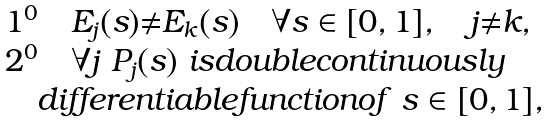<formula> <loc_0><loc_0><loc_500><loc_500>\begin{array} { l } 1 ^ { 0 } \quad E _ { j } ( s ) { \neq } E _ { k } ( s ) \quad \forall s \in [ 0 , 1 ] , \quad j { \neq } k , \\ 2 ^ { 0 } \quad \forall j \ P _ { j } ( s ) \ i s d o u b l e c o n t i n u o u s l y \\ \quad d i f f e r e n t i a b l e f u n c t i o n o f \ s \in [ 0 , 1 ] , \end{array}</formula> 